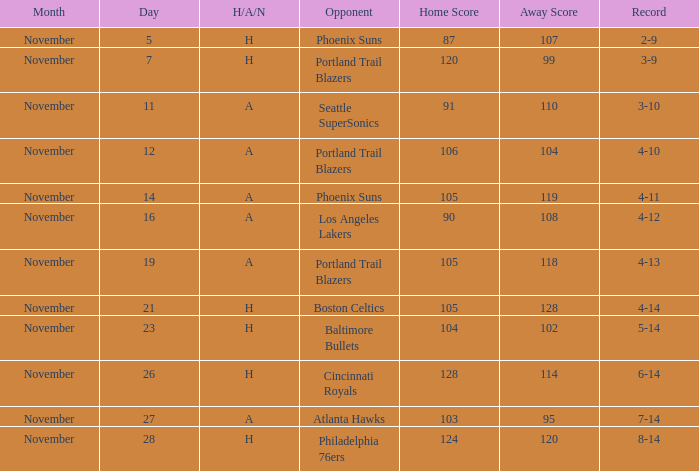On what Date was the Score 105-118 and the H/A/N A? November 19. 